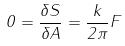Convert formula to latex. <formula><loc_0><loc_0><loc_500><loc_500>0 = \frac { \delta S } { \delta A } = \frac { k } { 2 \pi } F</formula> 